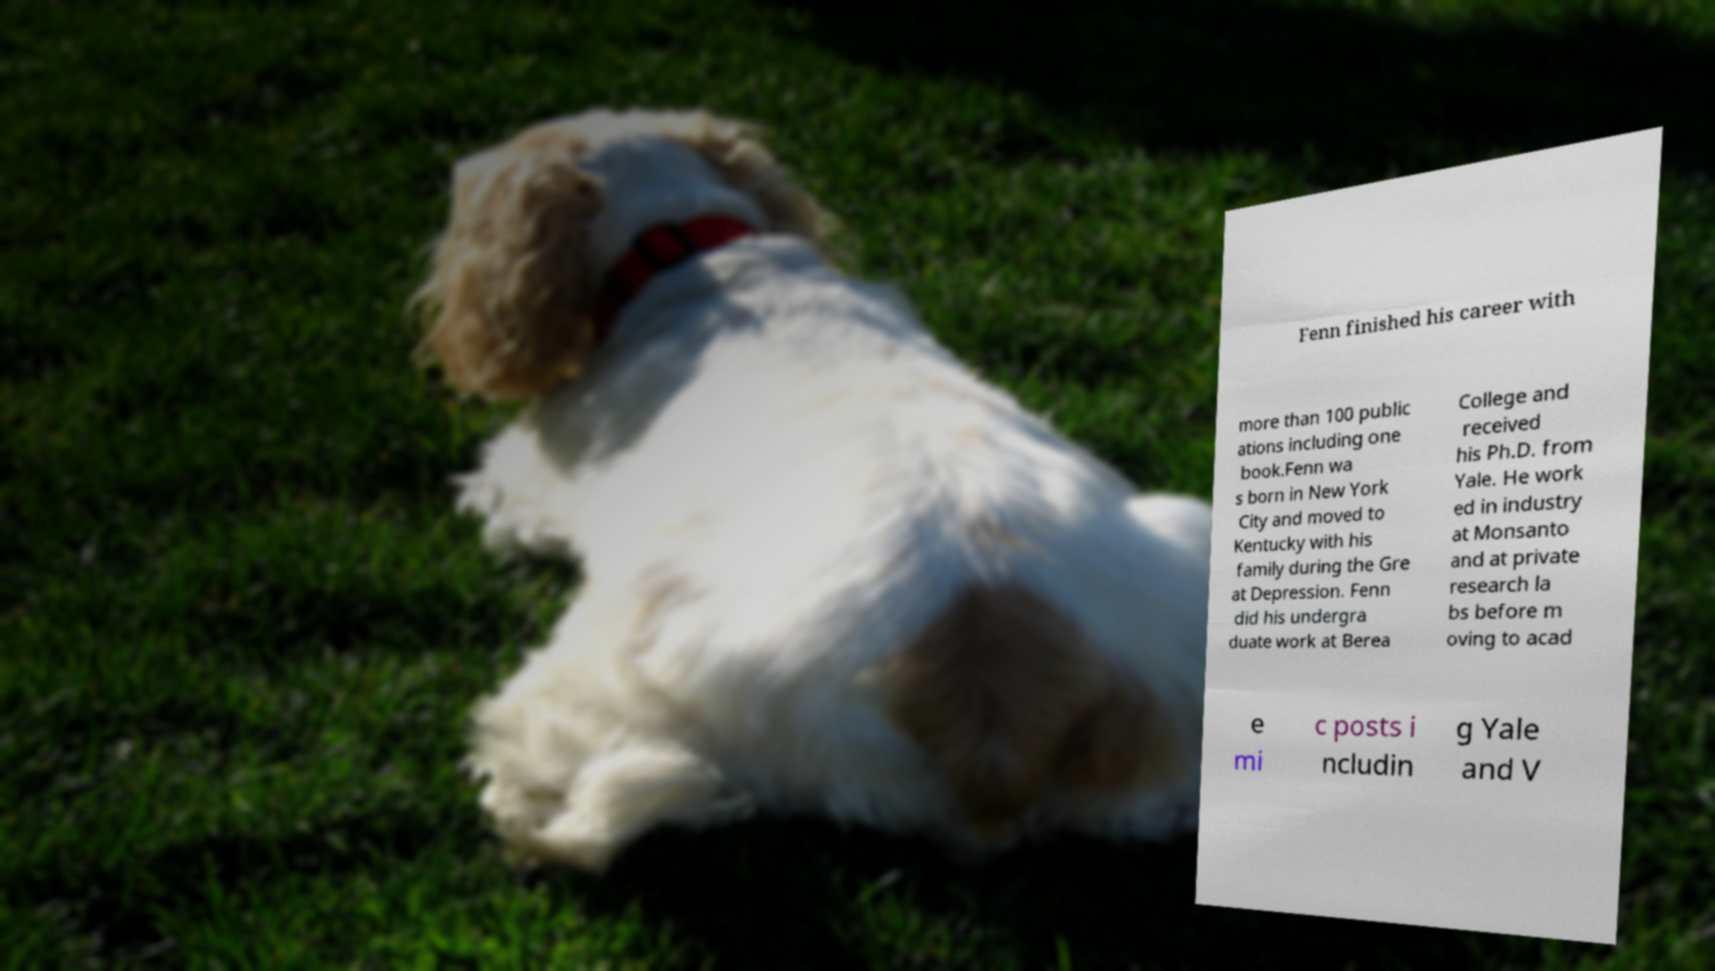Could you assist in decoding the text presented in this image and type it out clearly? Fenn finished his career with more than 100 public ations including one book.Fenn wa s born in New York City and moved to Kentucky with his family during the Gre at Depression. Fenn did his undergra duate work at Berea College and received his Ph.D. from Yale. He work ed in industry at Monsanto and at private research la bs before m oving to acad e mi c posts i ncludin g Yale and V 